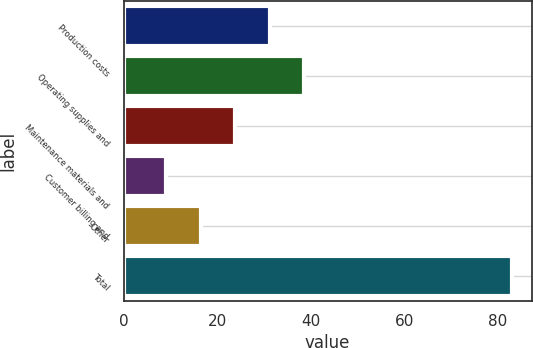Convert chart to OTSL. <chart><loc_0><loc_0><loc_500><loc_500><bar_chart><fcel>Production costs<fcel>Operating supplies and<fcel>Maintenance materials and<fcel>Customer billing and<fcel>Other<fcel>Total<nl><fcel>31.2<fcel>38.6<fcel>23.8<fcel>9<fcel>16.4<fcel>83<nl></chart> 